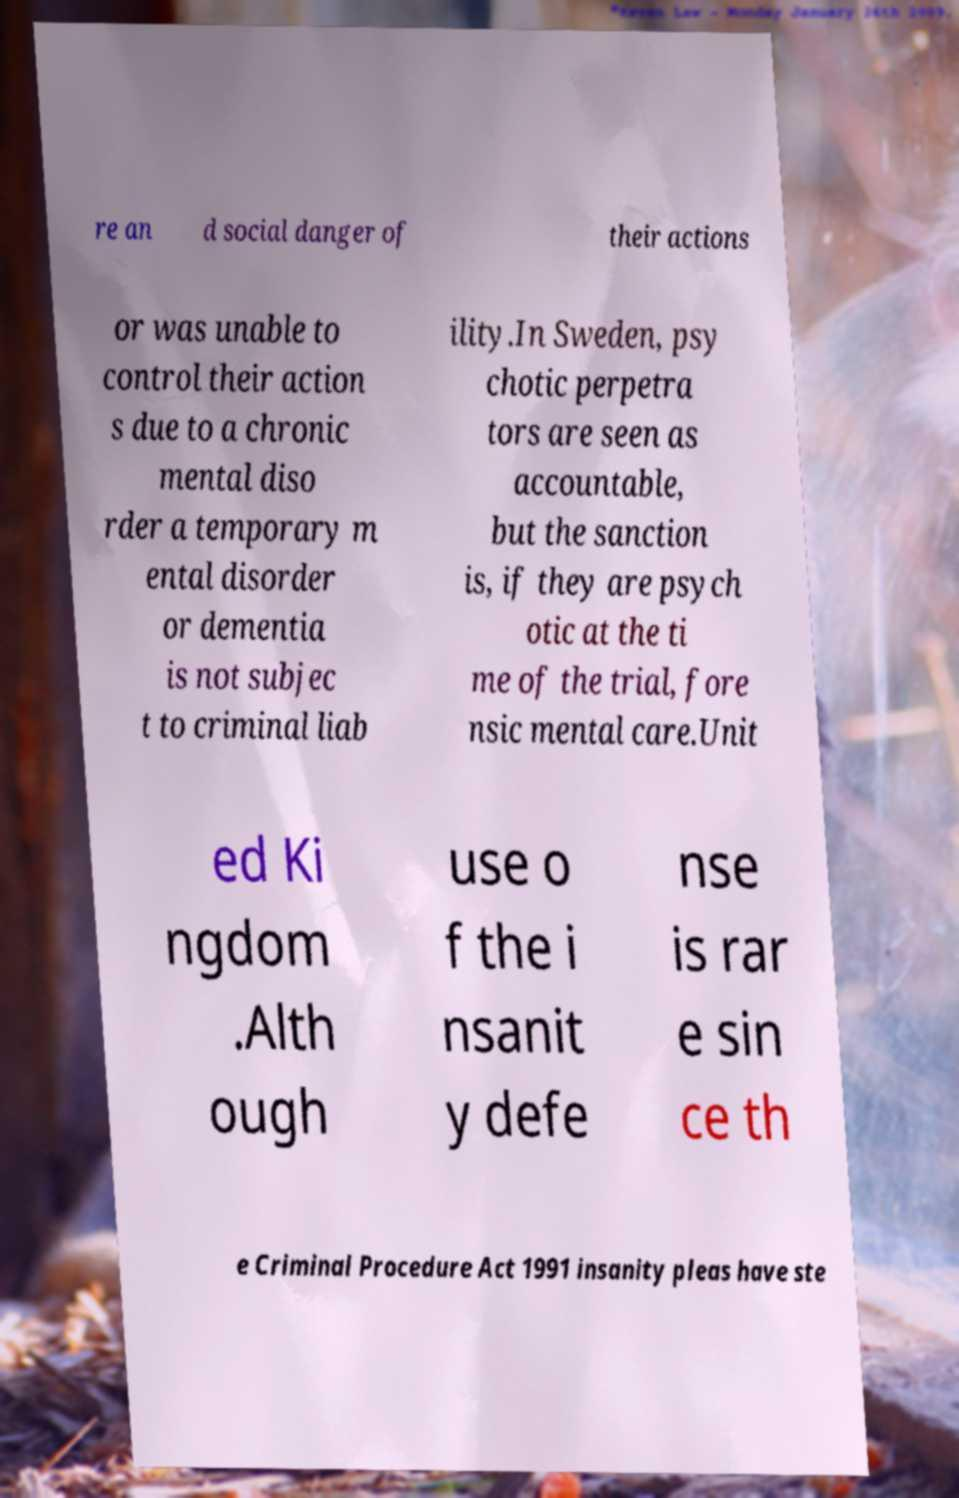Can you read and provide the text displayed in the image?This photo seems to have some interesting text. Can you extract and type it out for me? re an d social danger of their actions or was unable to control their action s due to a chronic mental diso rder a temporary m ental disorder or dementia is not subjec t to criminal liab ility.In Sweden, psy chotic perpetra tors are seen as accountable, but the sanction is, if they are psych otic at the ti me of the trial, fore nsic mental care.Unit ed Ki ngdom .Alth ough use o f the i nsanit y defe nse is rar e sin ce th e Criminal Procedure Act 1991 insanity pleas have ste 